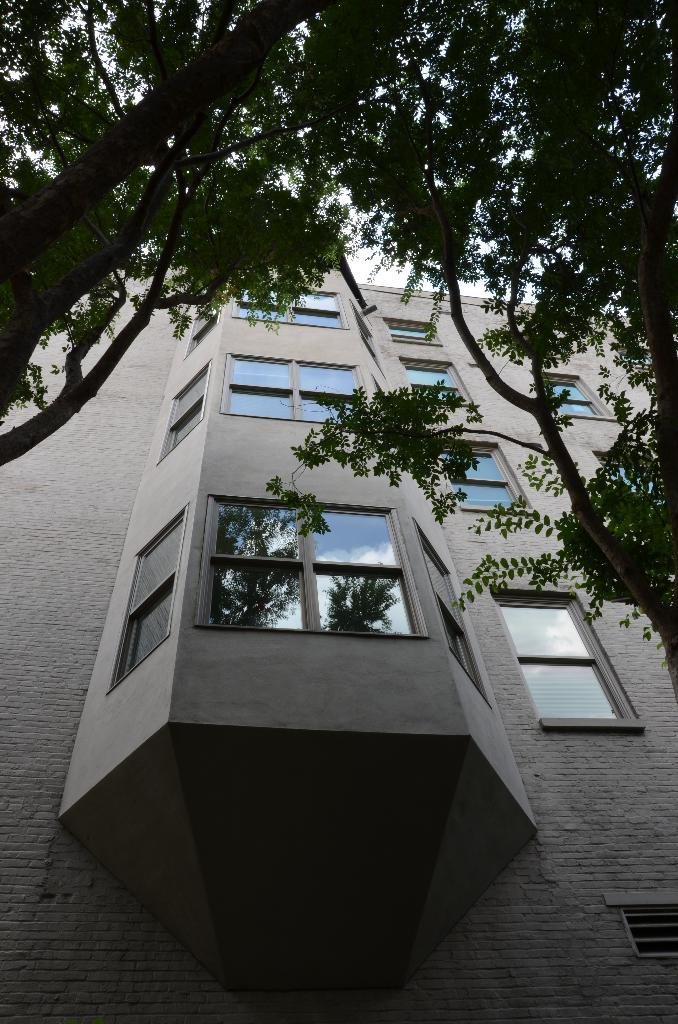What type of vegetation can be seen in the image? There are trees in the image. What type of structure is present in the image? There is a building with windows in the image. What can be seen in the background of the image? The sky is visible in the background of the image. What type of food is being served at the feast in the image? There is no feast or food present in the image; it features trees, a building, and the sky. What committee is responsible for the design of the building in the image? There is no information about a committee responsible for the design of the building in the image. 